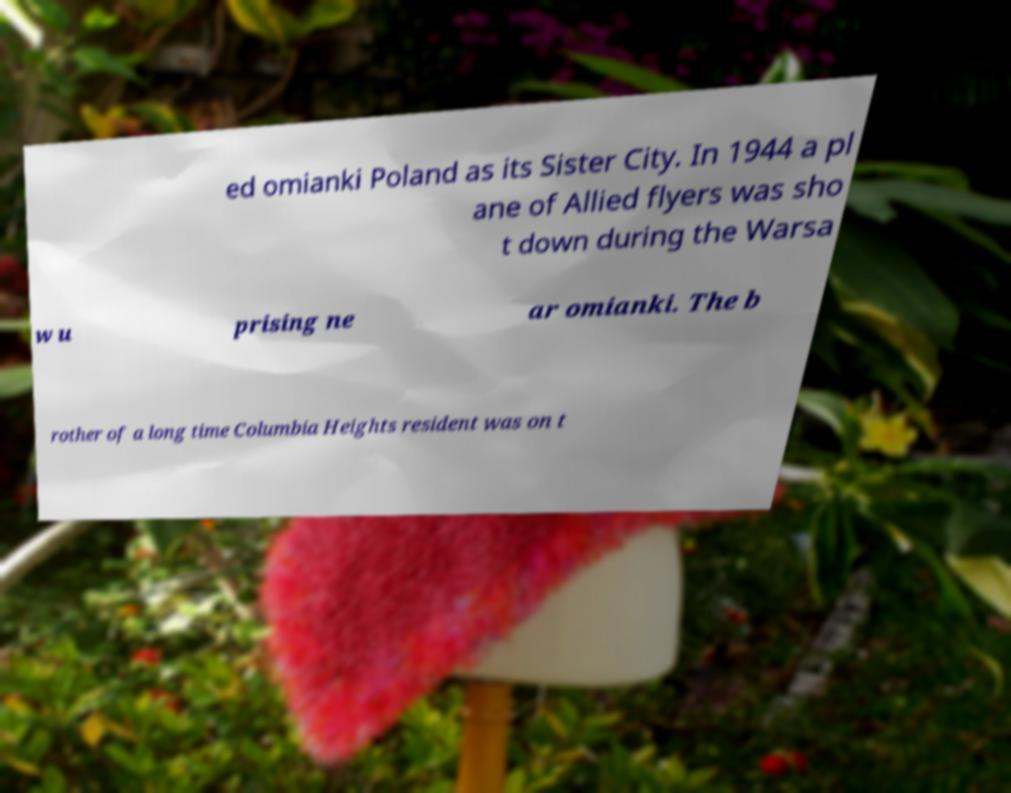I need the written content from this picture converted into text. Can you do that? ed omianki Poland as its Sister City. In 1944 a pl ane of Allied flyers was sho t down during the Warsa w u prising ne ar omianki. The b rother of a long time Columbia Heights resident was on t 